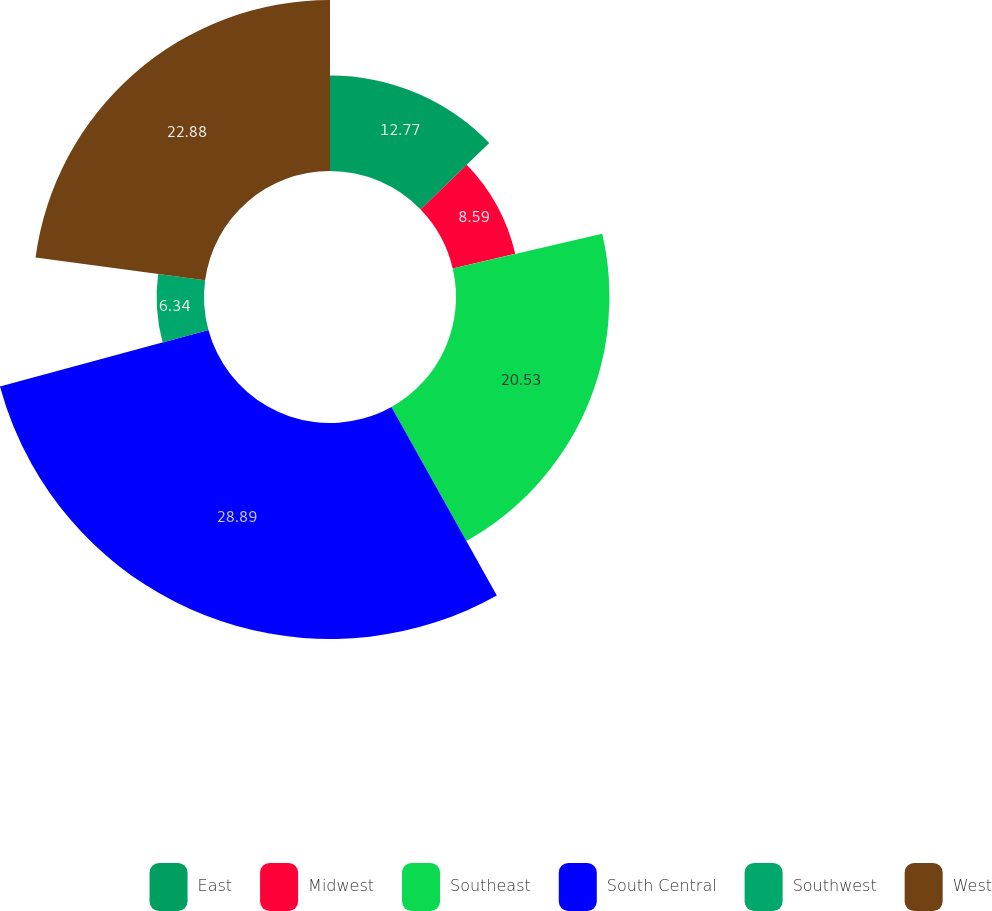Convert chart. <chart><loc_0><loc_0><loc_500><loc_500><pie_chart><fcel>East<fcel>Midwest<fcel>Southeast<fcel>South Central<fcel>Southwest<fcel>West<nl><fcel>12.77%<fcel>8.59%<fcel>20.53%<fcel>28.89%<fcel>6.34%<fcel>22.88%<nl></chart> 